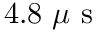<formula> <loc_0><loc_0><loc_500><loc_500>4 . 8 \mu s</formula> 